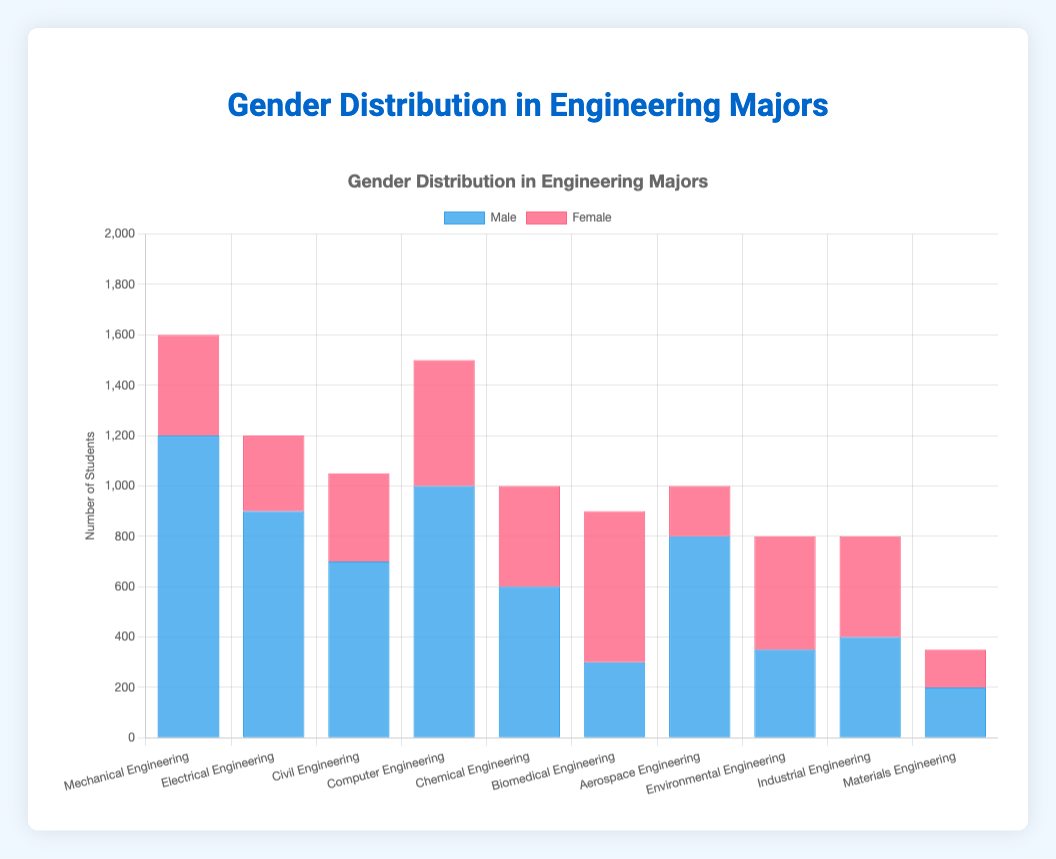What is the total number of students in Mechanical Engineering? To find the total number of students in Mechanical Engineering, sum the number of male and female students, which are 1200 and 400 respectively: 1200 + 400 = 1600
Answer: 1600 Which major has the highest number of female students? By examining the data for the female students in various majors, we can see that Biomedical Engineering has the highest count with 600 female students.
Answer: Biomedical Engineering Compare the number of male students in Mechanical Engineering and Electrical Engineering. Which major has more? The number of male students in Mechanical Engineering is 1200, and in Electrical Engineering, it is 900. Comparing 1200 and 900, Mechanical Engineering has more male students.
Answer: Mechanical Engineering What is the difference in the number of female students between Environmental Engineering and Aerospace Engineering? The number of female students in Environmental Engineering is 450, and in Aerospace Engineering, it is 200. The difference is calculated as: 450 - 200 = 250
Answer: 250 What is the average number of female students across all majors? Sum the number of female students in all majors and divide by the number of majors. The sum is 400 + 300 + 350 + 500 + 400 + 600 + 200 + 450 + 400 + 150 = 3750. There are 10 majors, so average = 3750 / 10 = 375
Answer: 375 Between which majors is there the largest discrepancy in the number of male students? The largest discrepancy is between Mechanical Engineering with 1200 male students and Materials Engineering with 200 male students. The difference is 1200 - 200 = 1000
Answer: Mechanical Engineering and Materials Engineering What is the total number of students in Biomedical Engineering? Sum the male and female students in Biomedical Engineering, which are 300 and 600 respectively: 300 + 600 = 900
Answer: 900 Which major has an equal number of male and female students? The data shows that Industrial Engineering has 400 male and 400 female students.
Answer: Industrial Engineering Among the given majors, which one has the least number of male students? Reviewing the male students' data, Materials Engineering has the least number of male students with 200.
Answer: Materials Engineering How many more female students are there in Biomedical Engineering compared to Chemical Engineering? Biomedical Engineering has 600 female students, and Chemical Engineering has 400. The difference is: 600 - 400 = 200
Answer: 200 